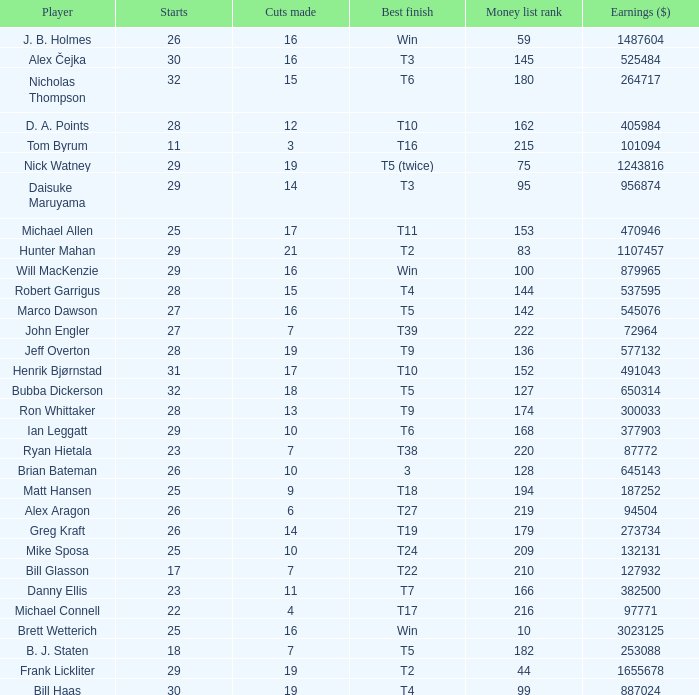What is the minimum money list rank for the players having a best finish of T9? 136.0. 